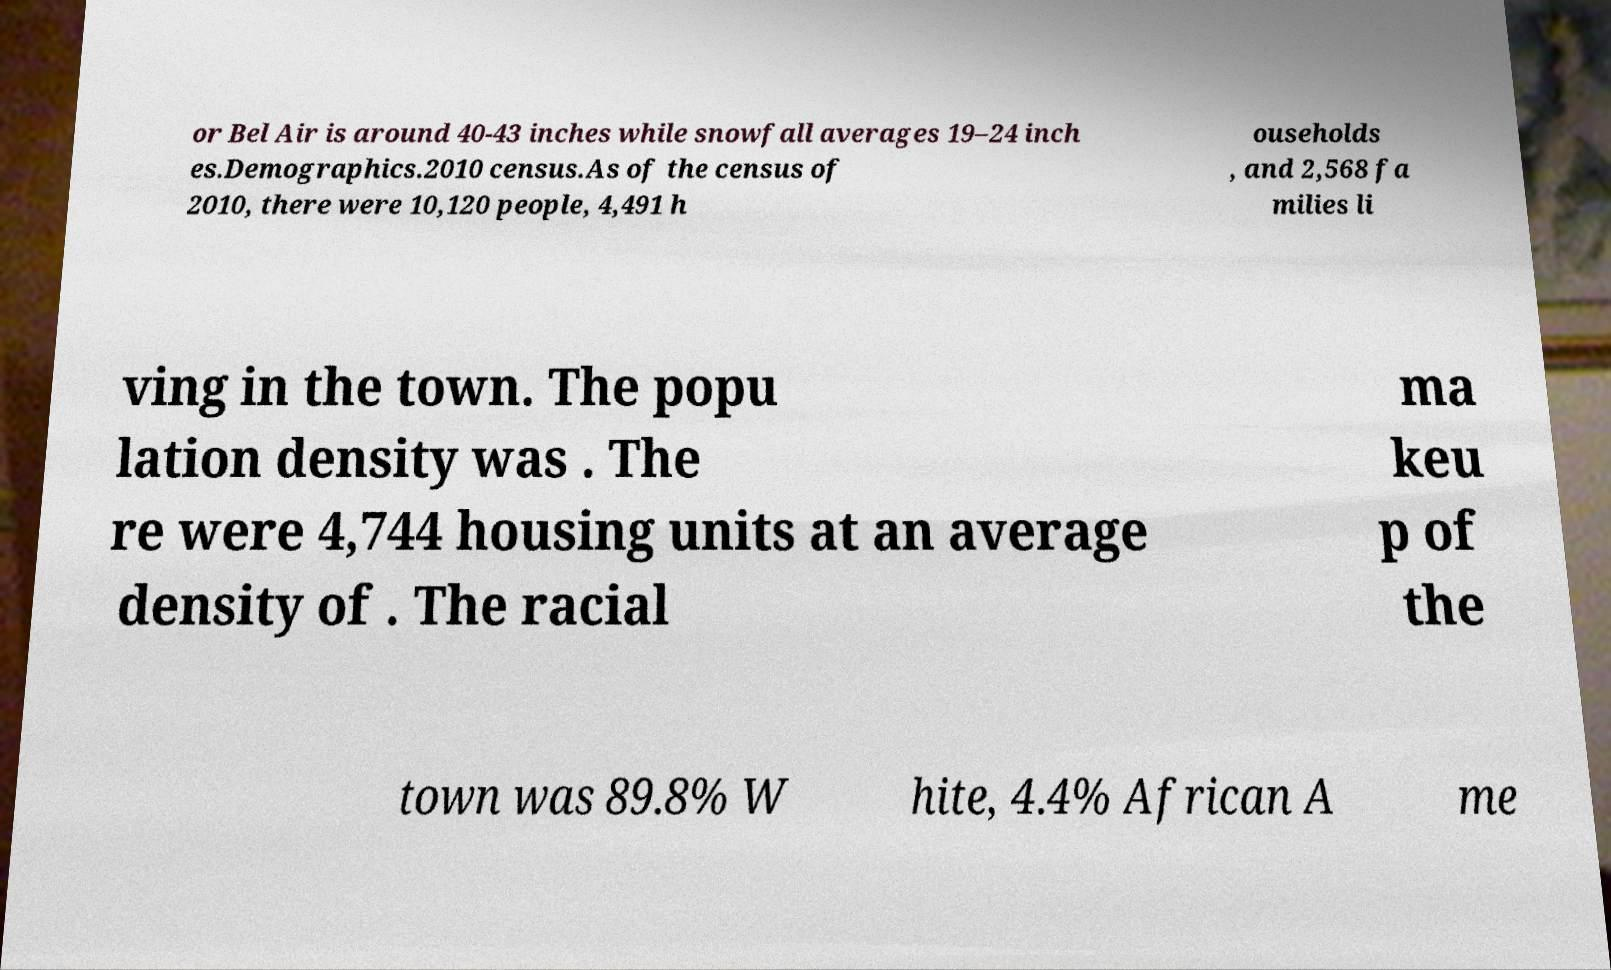For documentation purposes, I need the text within this image transcribed. Could you provide that? or Bel Air is around 40-43 inches while snowfall averages 19–24 inch es.Demographics.2010 census.As of the census of 2010, there were 10,120 people, 4,491 h ouseholds , and 2,568 fa milies li ving in the town. The popu lation density was . The re were 4,744 housing units at an average density of . The racial ma keu p of the town was 89.8% W hite, 4.4% African A me 